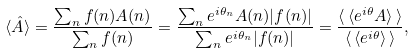Convert formula to latex. <formula><loc_0><loc_0><loc_500><loc_500>\langle \hat { A } \rangle = \frac { \sum _ { n } f ( n ) A ( n ) } { \sum _ { n } f ( n ) } = \frac { \sum _ { n } e ^ { i \theta _ { n } } A ( n ) | f ( n ) | } { \sum _ { n } e ^ { i \theta _ { n } } | f ( n ) | } = \frac { \langle \, \langle e ^ { i \theta } A \rangle \, \rangle } { \langle \, \langle e ^ { i \theta } \rangle \, \rangle } ,</formula> 